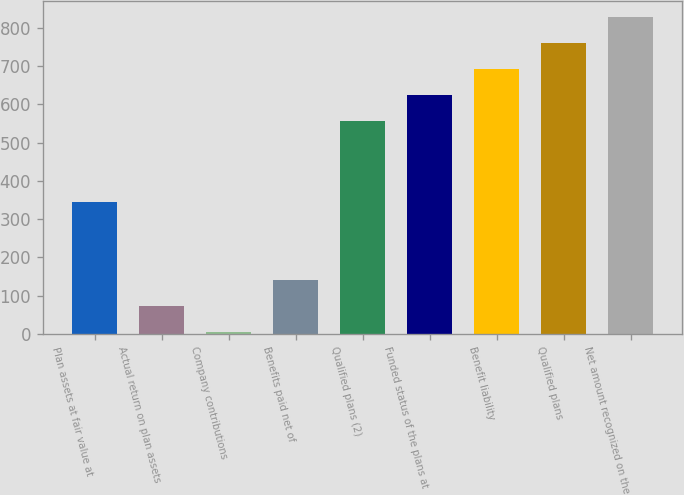Convert chart. <chart><loc_0><loc_0><loc_500><loc_500><bar_chart><fcel>Plan assets at fair value at<fcel>Actual return on plan assets<fcel>Company contributions<fcel>Benefits paid net of<fcel>Qualified plans (2)<fcel>Funded status of the plans at<fcel>Benefit liability<fcel>Qualified plans<fcel>Net amount recognized on the<nl><fcel>346<fcel>74<fcel>6<fcel>142<fcel>557<fcel>625<fcel>693<fcel>761<fcel>829<nl></chart> 